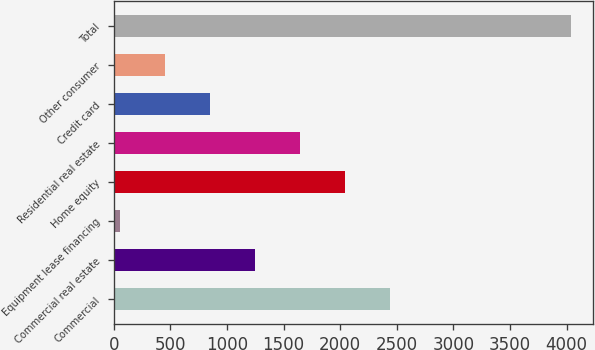Convert chart. <chart><loc_0><loc_0><loc_500><loc_500><bar_chart><fcel>Commercial<fcel>Commercial real estate<fcel>Equipment lease financing<fcel>Home equity<fcel>Residential real estate<fcel>Credit card<fcel>Other consumer<fcel>Total<nl><fcel>2443.2<fcel>1248.6<fcel>54<fcel>2045<fcel>1646.8<fcel>850.4<fcel>452.2<fcel>4036<nl></chart> 